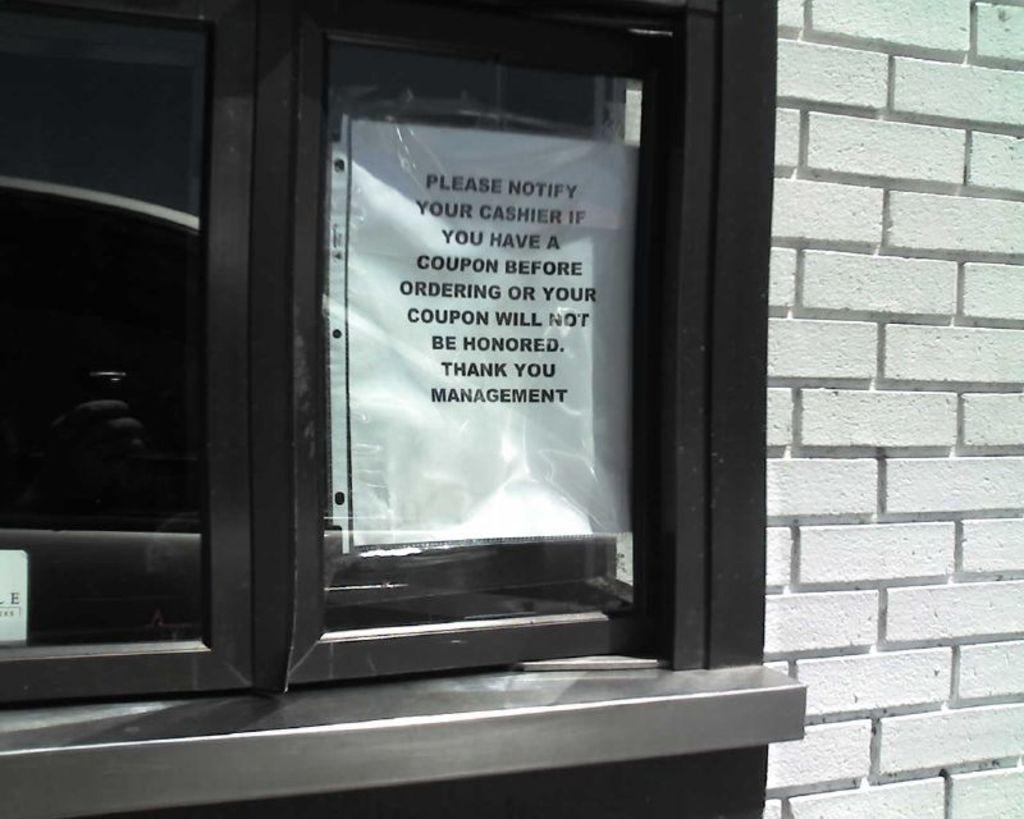Could you give a brief overview of what you see in this image? In this image there is a window on the left side of this image and there is one white color paper is attached on it. There is a wall on the right side of this image. 